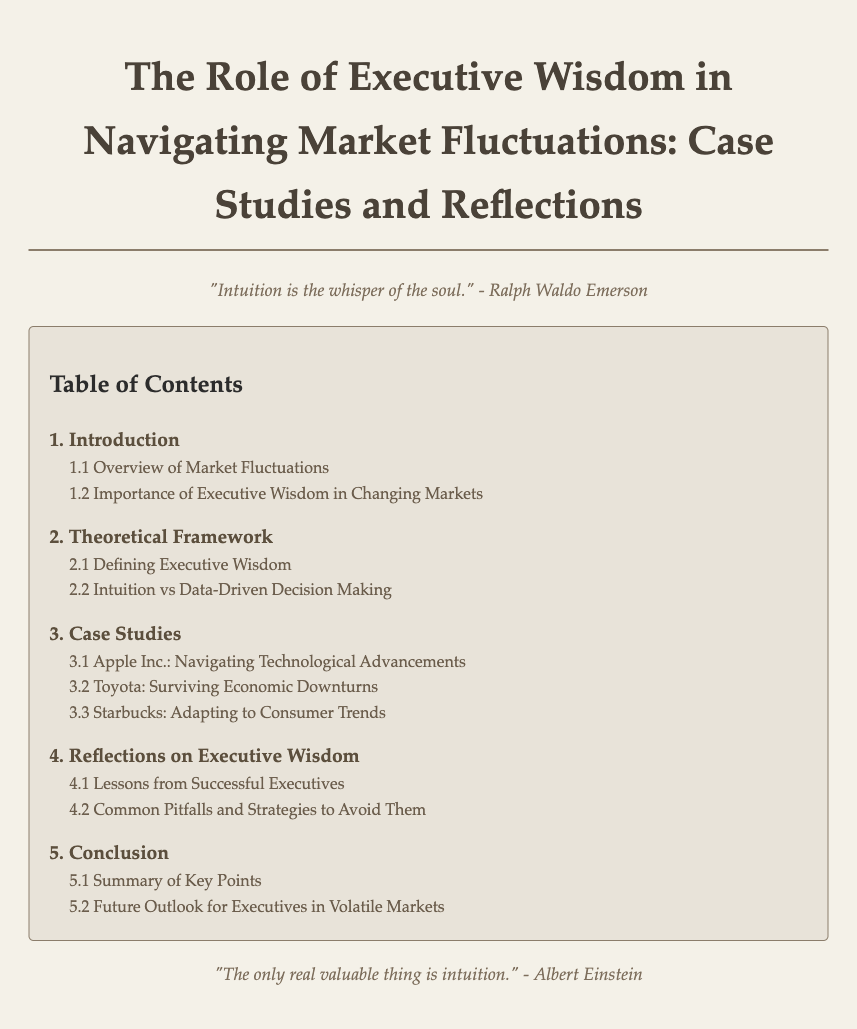What is the title of the document? The title is presented prominently at the top of the document, indicating the main focus of the content.
Answer: The Role of Executive Wisdom in Navigating Market Fluctuations: Case Studies and Reflections What chapter discusses the overview of market fluctuations? The chapter is identified in the Table of Contents along with its subtopics, detailing its focus on market changes.
Answer: 1. Introduction How many case studies are presented in the document? Counting the case studies listed under the respective chapter provides the total number of case studies included.
Answer: 3 Which company is studied in relation to adapting to consumer trends? The name of the company is mentioned in the case studies section, highlighting its focus on consumer behavior.
Answer: Starbucks What is one of the quotes included in the document? The document features quotes that emphasize the theme of intuition, which are explicitly mentioned in the text.
Answer: "Intuition is the whisper of the soul." - Ralph Waldo Emerson What section covers lessons from successful executives? This section focuses on insights gathered from leaders, providing guidance to others in similar positions.
Answer: 4.1 Lessons from Successful Executives Which chapter contrasts intuition with data-driven decision making? The specific subsection is part of the theoretical framework that differentiates between two decision-making approaches.
Answer: 2.2 Intuition vs Data-Driven Decision Making What is the final section of the document? The conclusion summarizes the content and provides a forward-looking perspective for executives in the market, as stated in the table of contents.
Answer: 5. Conclusion 